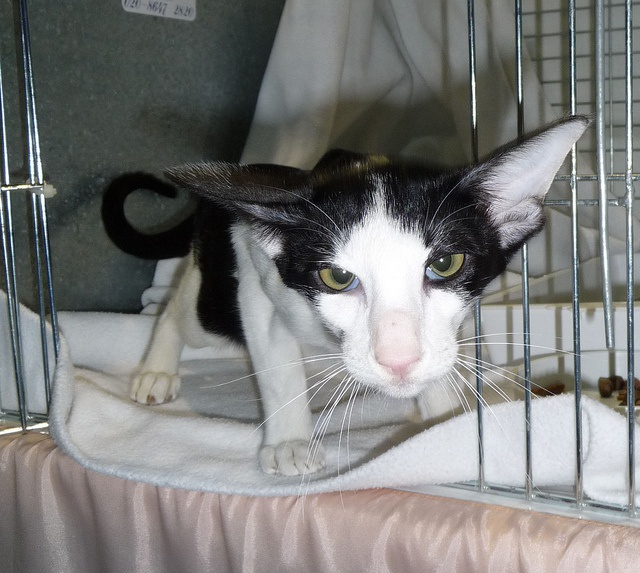Describe the objects in this image and their specific colors. I can see a cat in black, lightgray, darkgray, and gray tones in this image. 